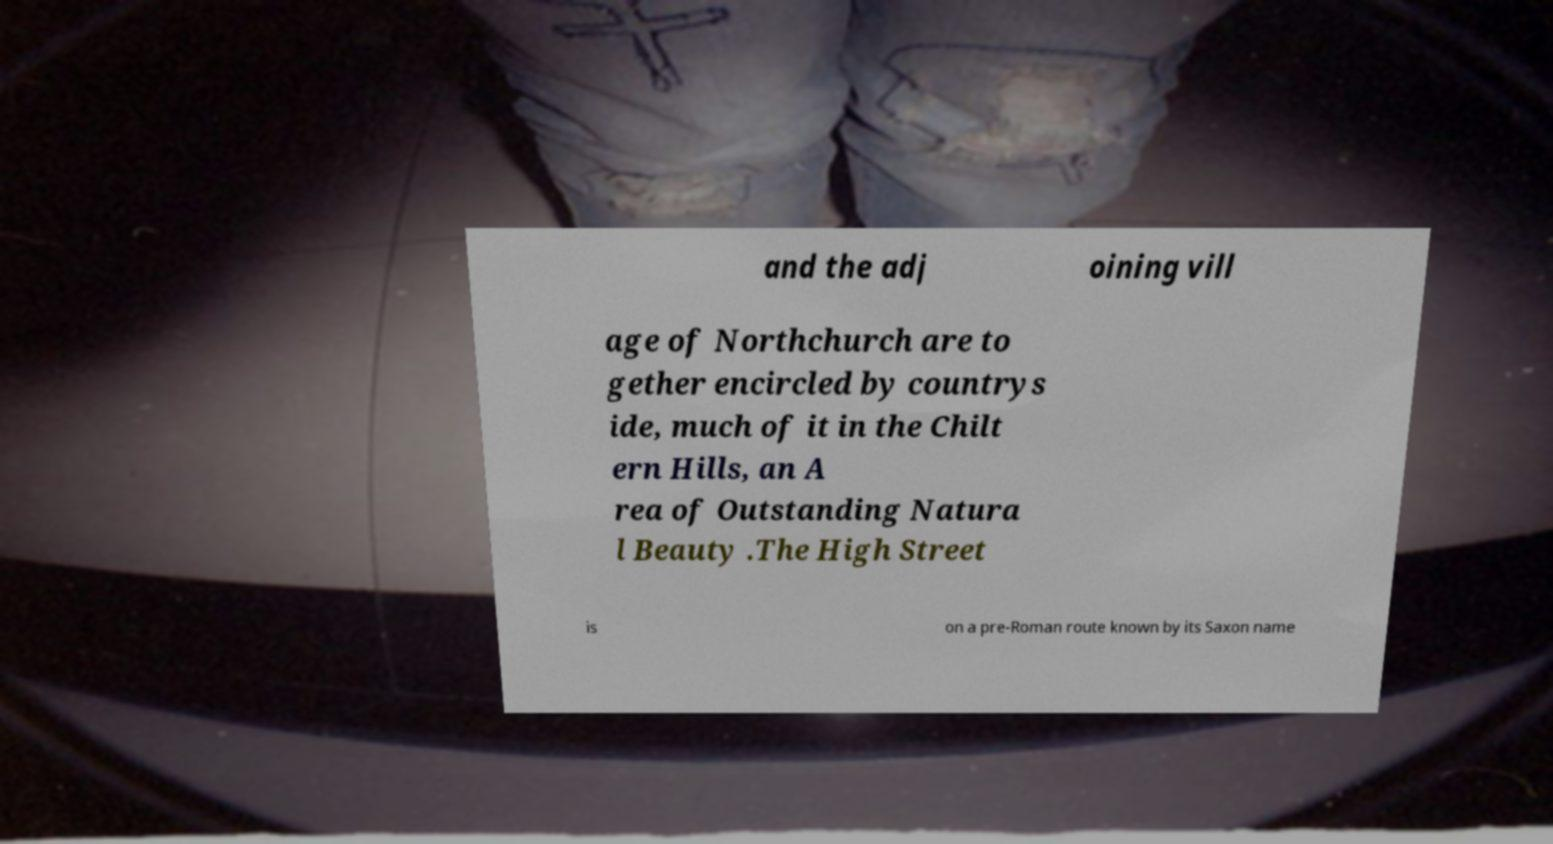I need the written content from this picture converted into text. Can you do that? and the adj oining vill age of Northchurch are to gether encircled by countrys ide, much of it in the Chilt ern Hills, an A rea of Outstanding Natura l Beauty .The High Street is on a pre-Roman route known by its Saxon name 